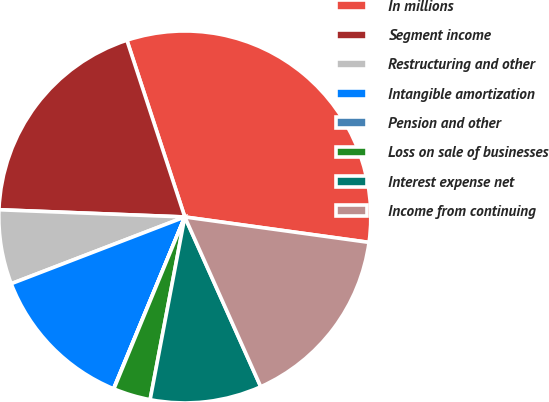<chart> <loc_0><loc_0><loc_500><loc_500><pie_chart><fcel>In millions<fcel>Segment income<fcel>Restructuring and other<fcel>Intangible amortization<fcel>Pension and other<fcel>Loss on sale of businesses<fcel>Interest expense net<fcel>Income from continuing<nl><fcel>32.22%<fcel>19.34%<fcel>6.46%<fcel>12.9%<fcel>0.03%<fcel>3.24%<fcel>9.68%<fcel>16.12%<nl></chart> 